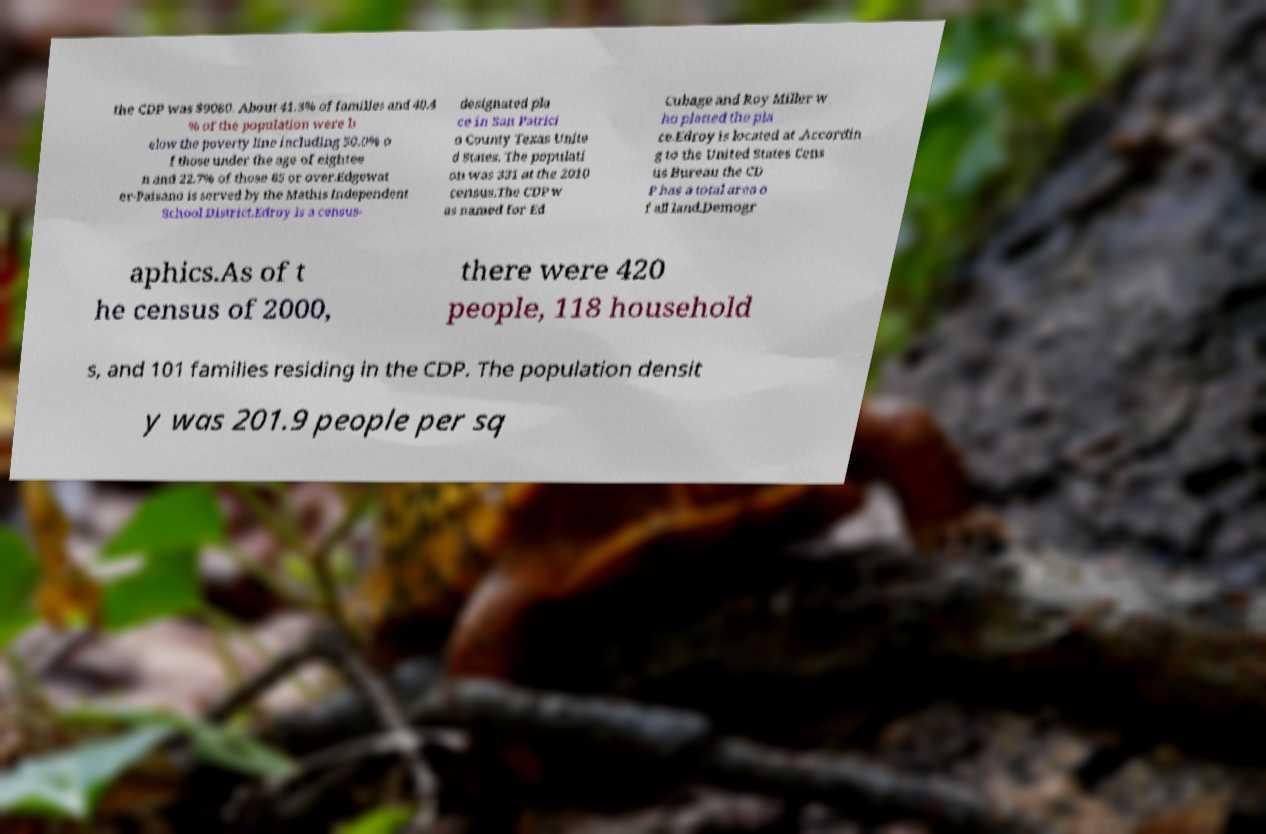Can you accurately transcribe the text from the provided image for me? the CDP was $9080. About 41.3% of families and 40.4 % of the population were b elow the poverty line including 50.0% o f those under the age of eightee n and 22.7% of those 65 or over.Edgewat er-Paisano is served by the Mathis Independent School District.Edroy is a census- designated pla ce in San Patrici o County Texas Unite d States. The populati on was 331 at the 2010 census.The CDP w as named for Ed Cubage and Roy Miller w ho platted the pla ce.Edroy is located at .Accordin g to the United States Cens us Bureau the CD P has a total area o f all land.Demogr aphics.As of t he census of 2000, there were 420 people, 118 household s, and 101 families residing in the CDP. The population densit y was 201.9 people per sq 